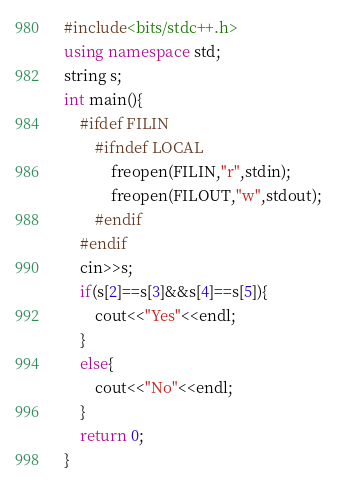Convert code to text. <code><loc_0><loc_0><loc_500><loc_500><_C++_>#include<bits/stdc++.h>
using namespace std;
string s;
int main(){
	#ifdef FILIN
		#ifndef LOCAL
			freopen(FILIN,"r",stdin);
			freopen(FILOUT,"w",stdout);
		#endif
	#endif
	cin>>s;
	if(s[2]==s[3]&&s[4]==s[5]){
		cout<<"Yes"<<endl;
	}
	else{
		cout<<"No"<<endl;
	}
	return 0;
}
</code> 